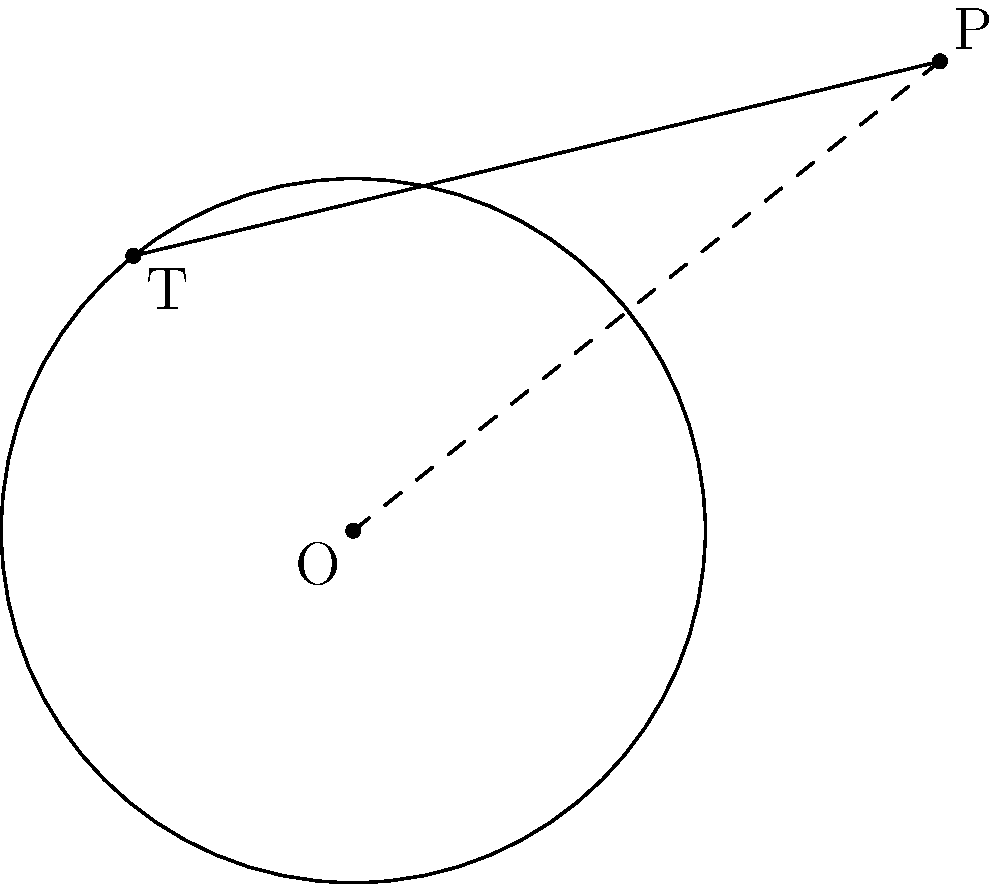As part of a media investment project, you're analyzing the geometry of satellite dish placement. A circular reflector with radius $r = 3$ units is centered at point O. A signal receiver is placed at an external point P, which is at a distance $d = 5$ units from the center O. What is the length of the tangent line $x$ from point P to the circle? Let's approach this step-by-step:

1) In a right-angled triangle formed by the tangent line, the radius to the point of tangency, and the line from the center to the external point:
   - The tangent line is perpendicular to the radius at the point of tangency.
   - This forms a right-angled triangle.

2) We can use the Pythagorean theorem in this right-angled triangle:
   $d^2 = r^2 + x^2$

3) We know:
   $d = 5$ (distance from center to external point)
   $r = 3$ (radius of the circle)

4) Substituting these values into the Pythagorean theorem:
   $5^2 = 3^2 + x^2$

5) Simplify:
   $25 = 9 + x^2$

6) Subtract 9 from both sides:
   $16 = x^2$

7) Take the square root of both sides:
   $x = \sqrt{16} = 4$

Therefore, the length of the tangent line from the external point P to the circle is 4 units.
Answer: 4 units 